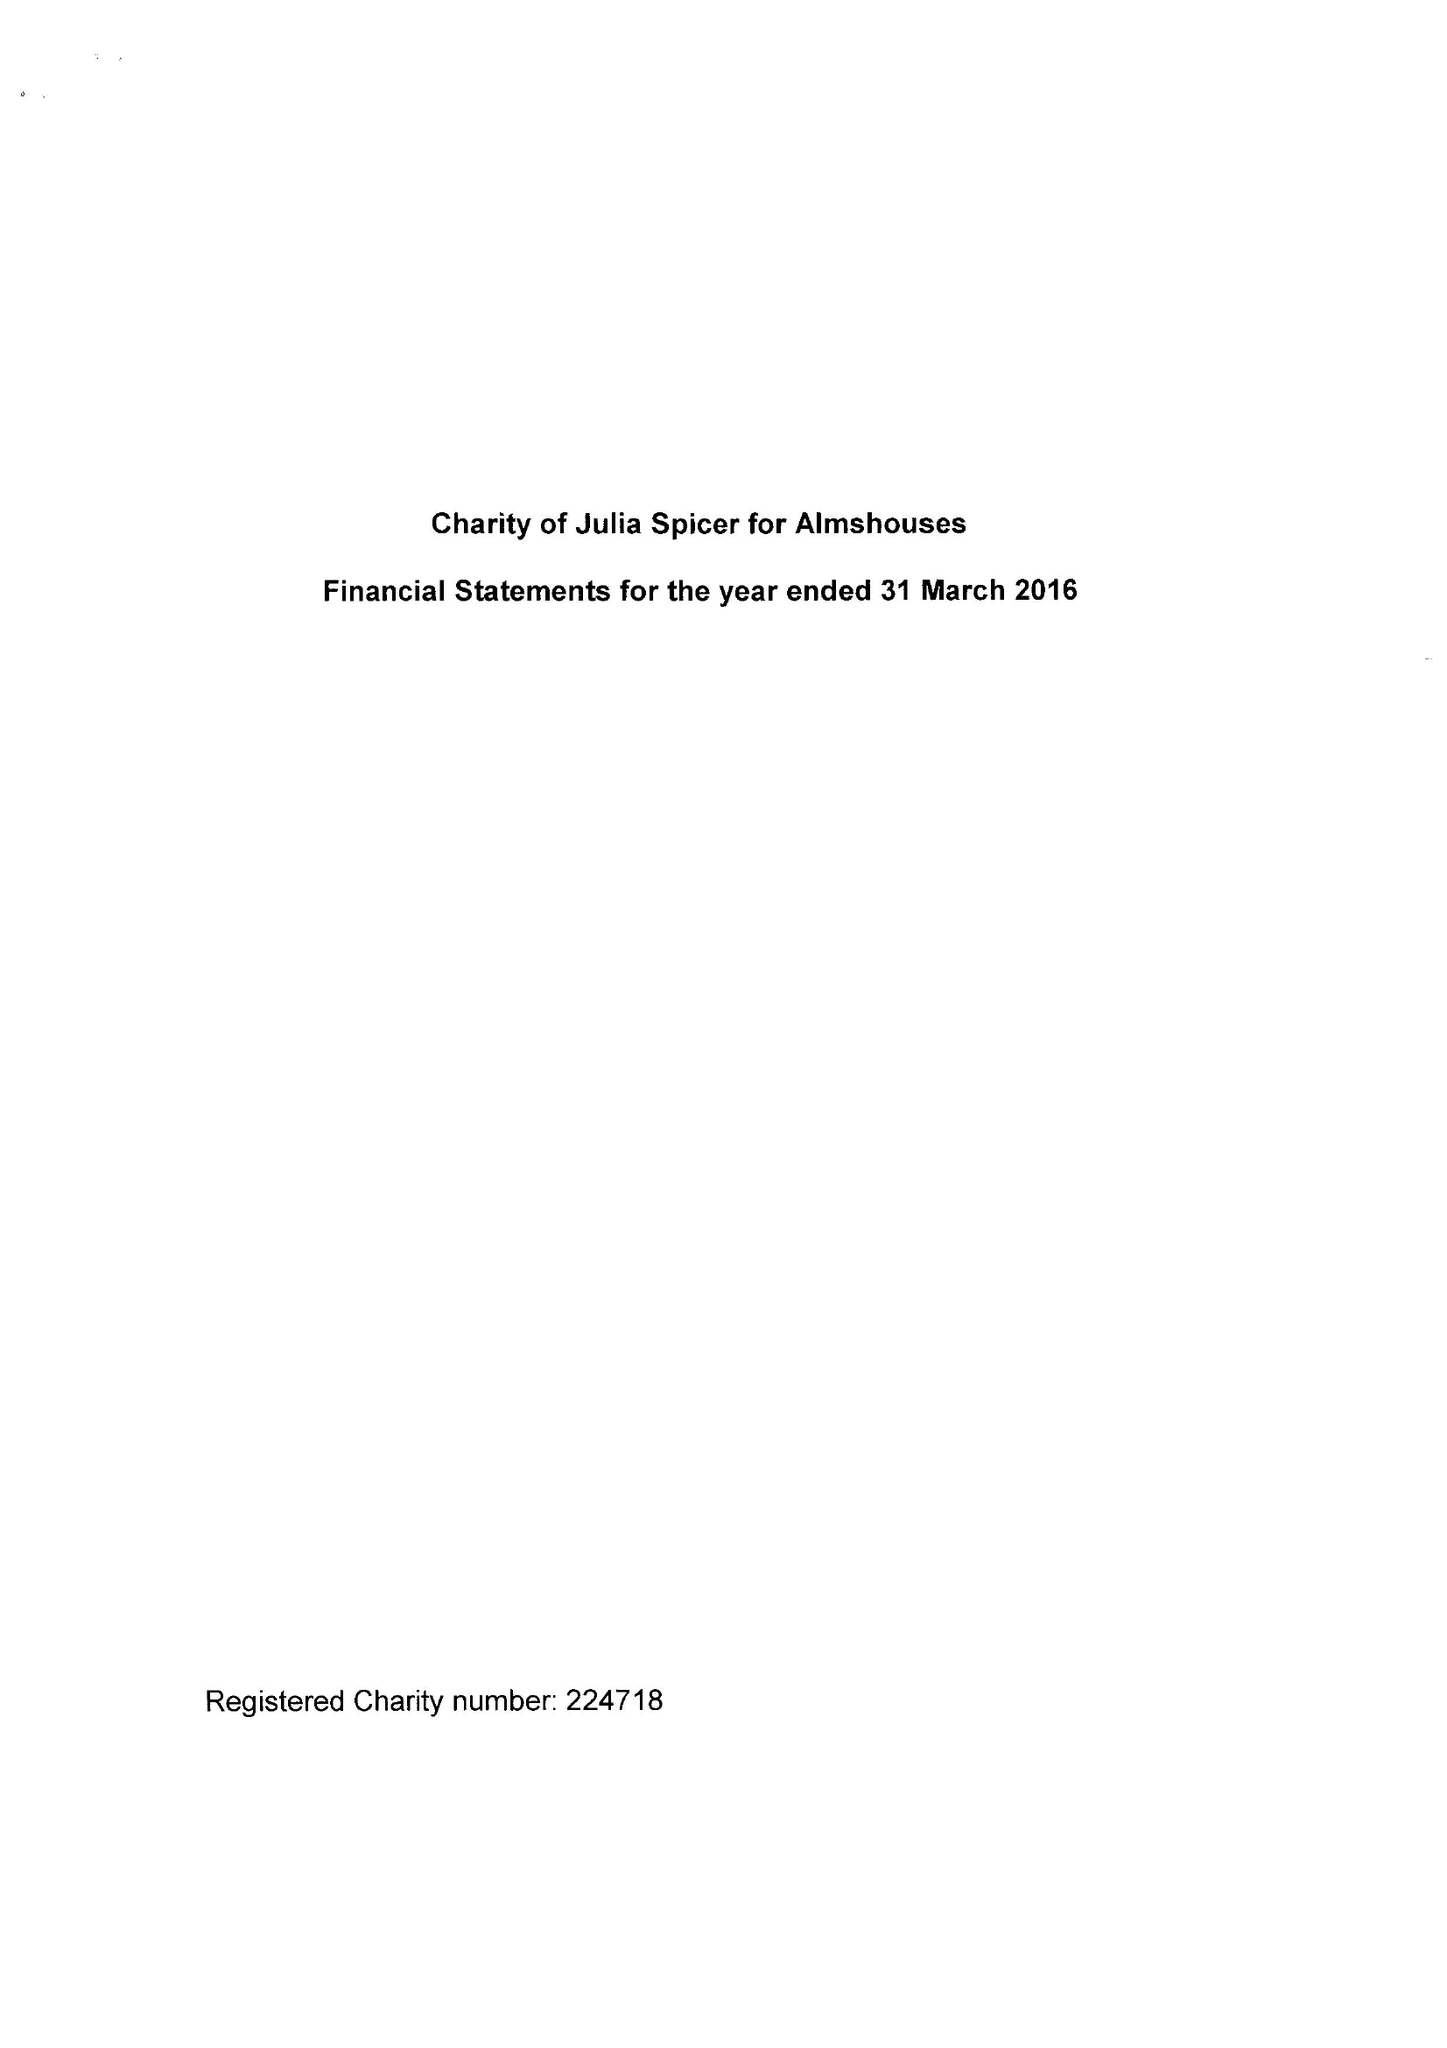What is the value for the address__postcode?
Answer the question using a single word or phrase. CR0 9XP 